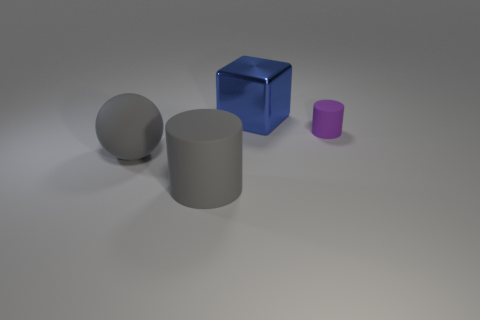What number of other objects are there of the same color as the large rubber sphere?
Offer a very short reply. 1. The matte thing that is both behind the big gray rubber cylinder and on the left side of the blue metal object is what color?
Provide a short and direct response. Gray. How many cubes are either small cyan shiny things or purple matte objects?
Keep it short and to the point. 0. How many shiny things have the same size as the blue block?
Ensure brevity in your answer.  0. How many big objects are in front of the gray rubber object behind the large gray rubber cylinder?
Provide a succinct answer. 1. There is a object that is both behind the big sphere and in front of the blue metal block; how big is it?
Provide a succinct answer. Small. Is the number of shiny cubes greater than the number of gray things?
Provide a succinct answer. No. Are there any small matte blocks that have the same color as the large ball?
Ensure brevity in your answer.  No. There is a cylinder on the left side of the cube; is its size the same as the large shiny cube?
Keep it short and to the point. Yes. Is the number of metallic things less than the number of red shiny cylinders?
Provide a succinct answer. No. 